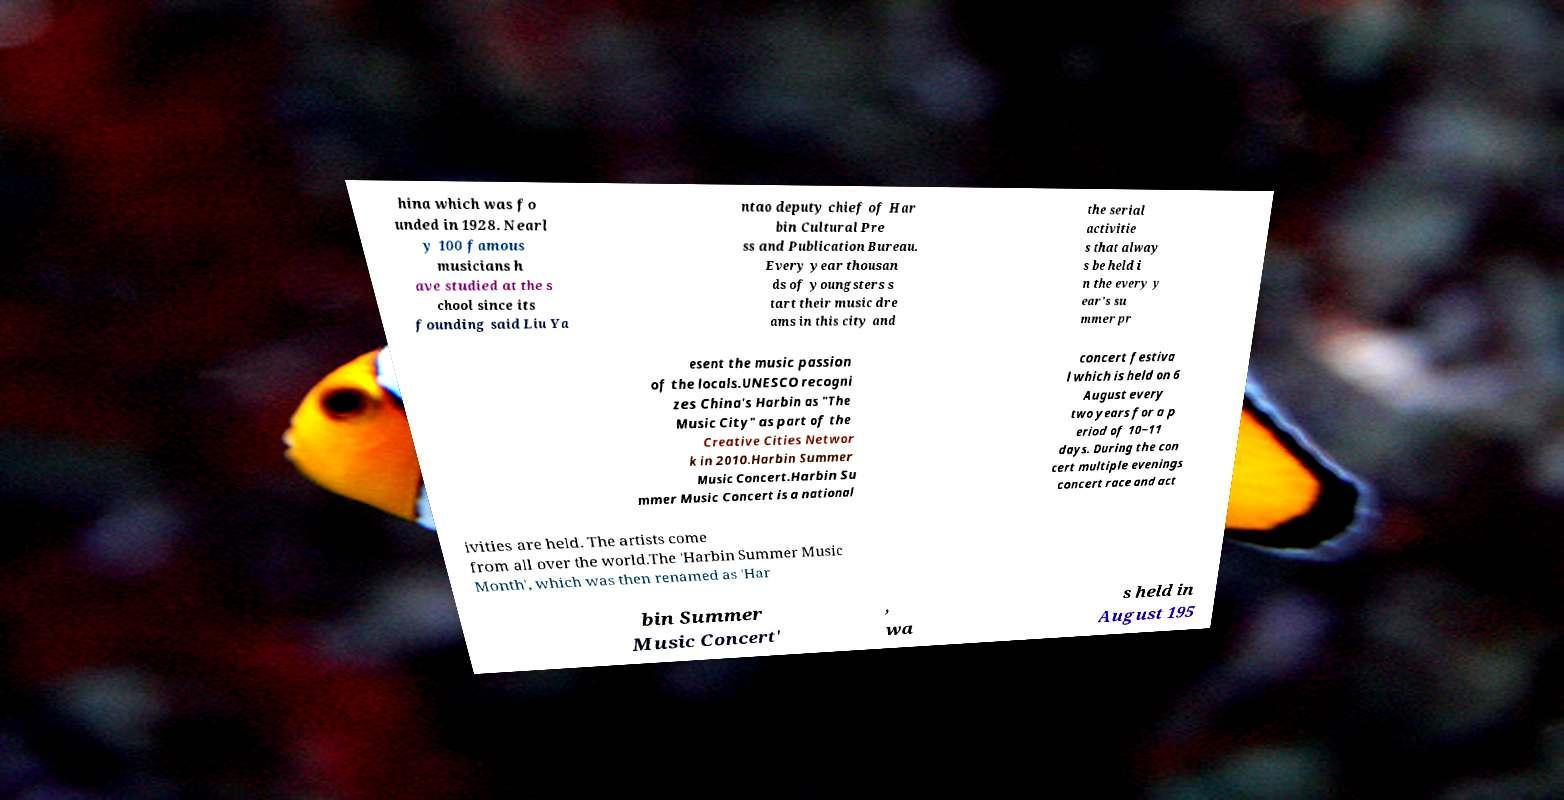Please identify and transcribe the text found in this image. hina which was fo unded in 1928. Nearl y 100 famous musicians h ave studied at the s chool since its founding said Liu Ya ntao deputy chief of Har bin Cultural Pre ss and Publication Bureau. Every year thousan ds of youngsters s tart their music dre ams in this city and the serial activitie s that alway s be held i n the every y ear's su mmer pr esent the music passion of the locals.UNESCO recogni zes China's Harbin as "The Music City" as part of the Creative Cities Networ k in 2010.Harbin Summer Music Concert.Harbin Su mmer Music Concert is a national concert festiva l which is held on 6 August every two years for a p eriod of 10~11 days. During the con cert multiple evenings concert race and act ivities are held. The artists come from all over the world.The 'Harbin Summer Music Month', which was then renamed as 'Har bin Summer Music Concert' , wa s held in August 195 